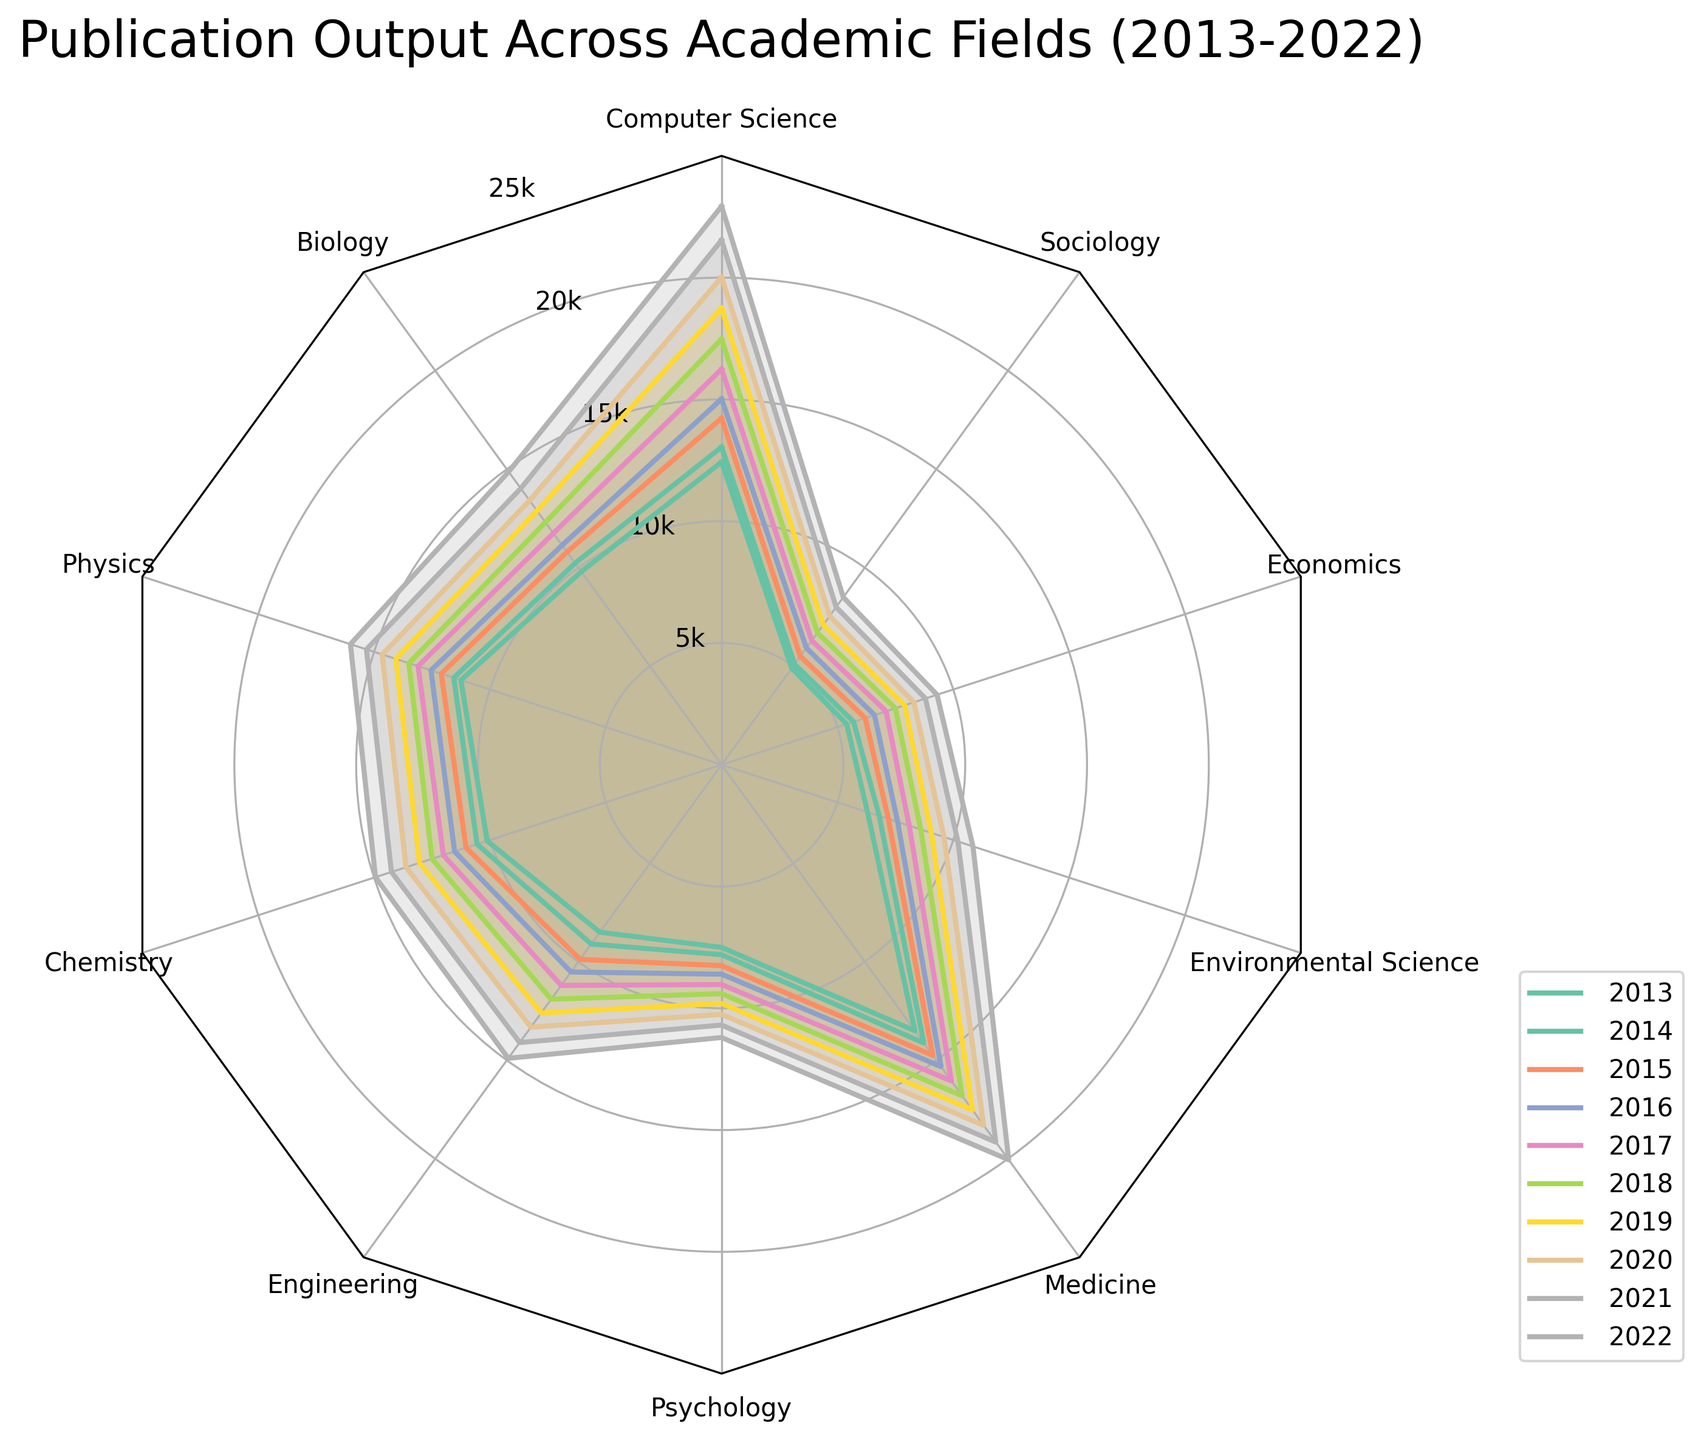How many academic fields are included in the radar chart? Counting the number of field labels around the radar chart, we find there are 10 fields: Computer Science, Biology, Physics, Chemistry, Engineering, Psychology, Medicine, Environmental Science, Economics, and Sociology.
Answer: 10 Which field had the highest publication output in 2022? The highest point in the 2022 polygon corresponds to Medicine, showing the largest value in the radar chart for that year.
Answer: Medicine What is the difference in publication output between Computer Science and Sociology in 2022? In 2022, Computer Science had 22,930 publications, while Sociology had 8,500. The difference is 22,930 - 8,500 = 14,430.
Answer: 14,430 In which field did the publication output grow the most from 2013 to 2022? By comparing the growth in publication outputs from 2013 to 2022 for each field, Computer Science had an increase from 12,430 to 22,930, which is the largest increase of 10,500 among all fields.
Answer: Computer Science How does the publication output in Computer Science in 2013 compare to that in Biology in 2022? In 2013, Computer Science had 12,430 publications, while in 2022, Biology had 14,870 publications. Biology had more publications than Computer Science in those respective years.
Answer: Biology had more Which two fields showed the closest publication output in 2018? By examining the points for 2018 on the radar chart, the fields Chemistry and Engineering show very close publication outputs at 12,500 and 11,900 respectively, with only a 600 publication difference.
Answer: Chemistry and Engineering What is the average publication output of Medicine over the decade? Summing the publication outputs of Medicine from 2013 to 2022: 13500 + 14120 + 14750 + 15320 + 16050 + 16800 + 17520 + 18300 + 19150 + 20050 = 165060. Dividing by 10 gives the average: 165060 / 10 = 16506.
Answer: 16,506 Which field had the smallest publication output increase from 2013 to 2022? Environmental Science's publication output increased from 6,300 in 2013 to 10,850 in 2022, an increase of 4,550 which is the smallest compared to other fields.
Answer: Environmental Science Which year had the overall highest publication outputs across all fields? By observing the polygons, the 2022 polygon is the outermost, indicating it had the highest overall publication outputs across all fields.
Answer: 2022 